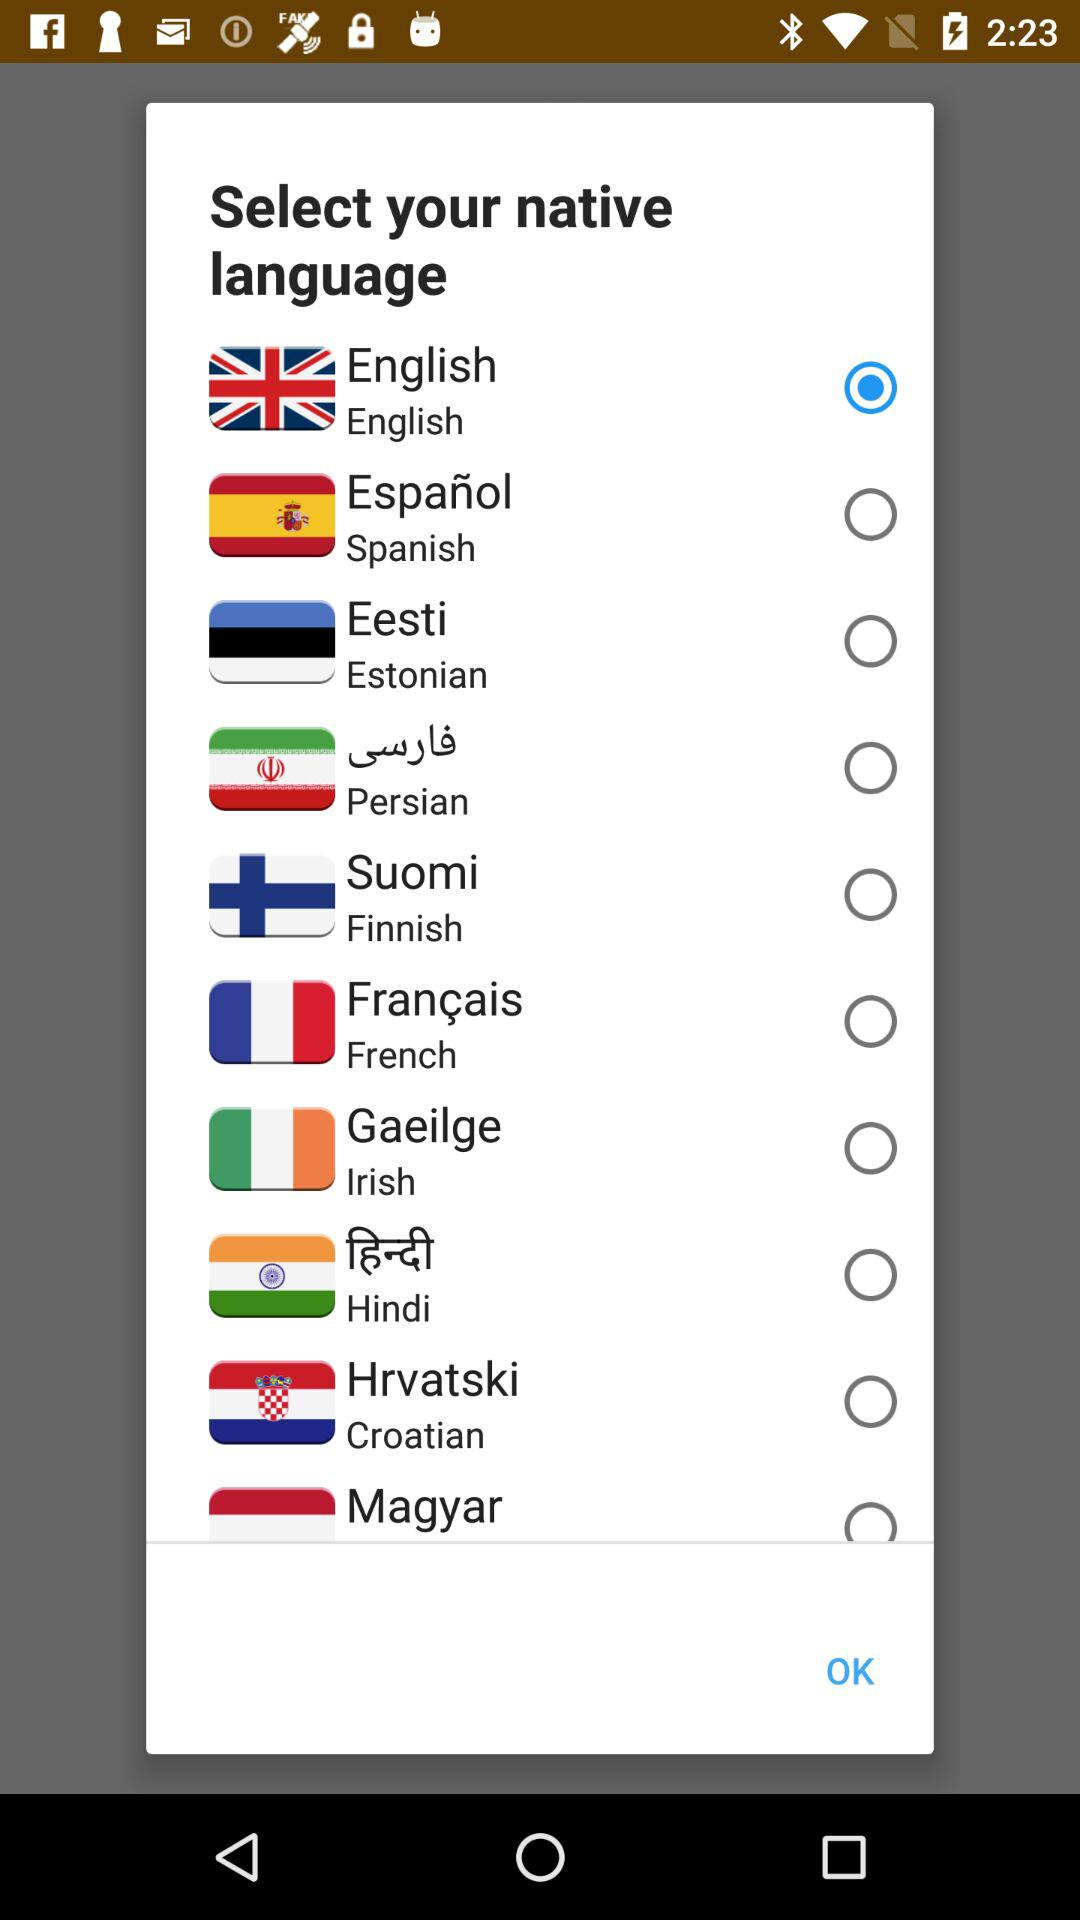What's the selected native language? The selected native language is English. 